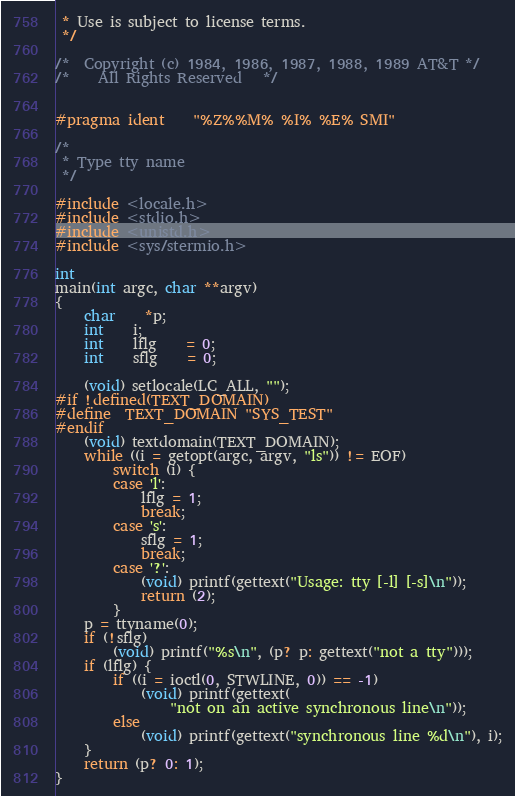<code> <loc_0><loc_0><loc_500><loc_500><_C_> * Use is subject to license terms.
 */

/*	Copyright (c) 1984, 1986, 1987, 1988, 1989 AT&T	*/
/*	  All Rights Reserved  	*/


#pragma ident	"%Z%%M%	%I%	%E% SMI"

/*
 * Type tty name
 */

#include <locale.h>
#include <stdio.h>
#include <unistd.h>
#include <sys/stermio.h>

int
main(int argc, char **argv)
{
	char	*p;
	int	i;
	int	lflg	= 0;
	int	sflg	= 0;

	(void) setlocale(LC_ALL, "");
#if !defined(TEXT_DOMAIN)
#define	TEXT_DOMAIN "SYS_TEST"
#endif
	(void) textdomain(TEXT_DOMAIN);
	while ((i = getopt(argc, argv, "ls")) != EOF)
		switch (i) {
		case 'l':
			lflg = 1;
			break;
		case 's':
			sflg = 1;
			break;
		case '?':
			(void) printf(gettext("Usage: tty [-l] [-s]\n"));
			return (2);
		}
	p = ttyname(0);
	if (!sflg)
		(void) printf("%s\n", (p? p: gettext("not a tty")));
	if (lflg) {
		if ((i = ioctl(0, STWLINE, 0)) == -1)
			(void) printf(gettext(
			    "not on an active synchronous line\n"));
		else
			(void) printf(gettext("synchronous line %d\n"), i);
	}
	return (p? 0: 1);
}
</code> 